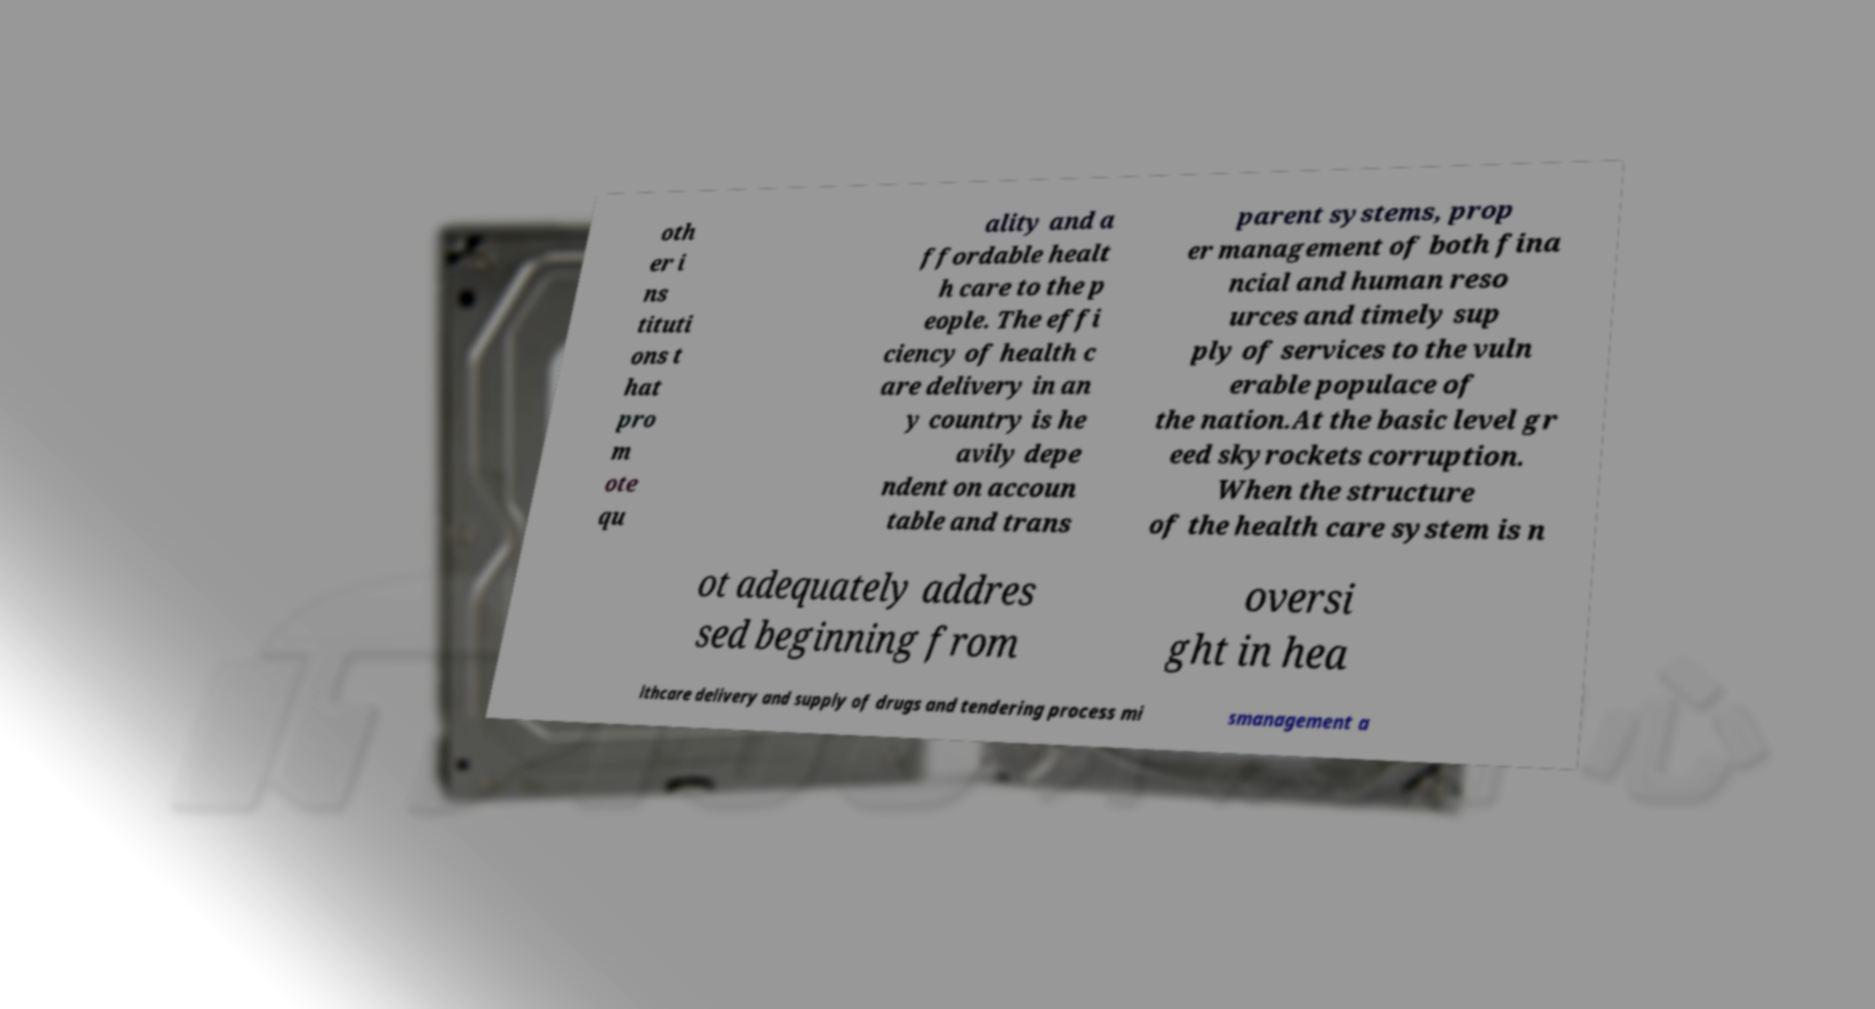Please identify and transcribe the text found in this image. oth er i ns tituti ons t hat pro m ote qu ality and a ffordable healt h care to the p eople. The effi ciency of health c are delivery in an y country is he avily depe ndent on accoun table and trans parent systems, prop er management of both fina ncial and human reso urces and timely sup ply of services to the vuln erable populace of the nation.At the basic level gr eed skyrockets corruption. When the structure of the health care system is n ot adequately addres sed beginning from oversi ght in hea lthcare delivery and supply of drugs and tendering process mi smanagement a 